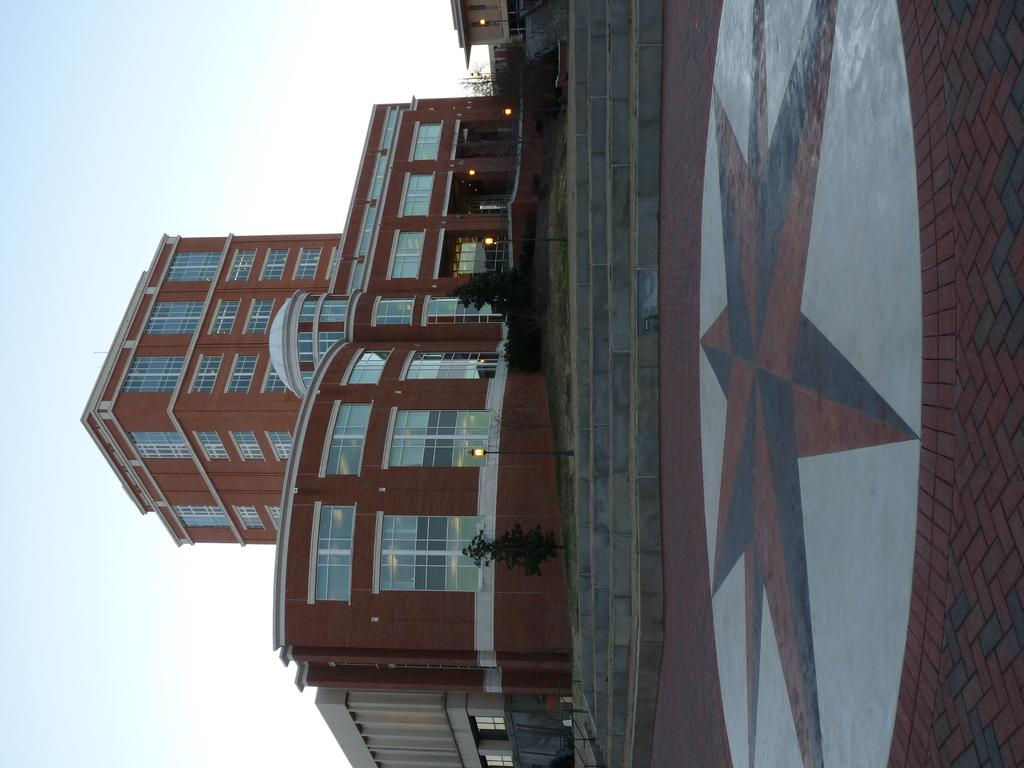What type of structure is present in the image? There is a building in the image. What can be seen in front of the building? There are plants and stairs in front of the building. Can you describe the ground in the image? The ground has a design. What is visible at the top of the image? The sky is visible at the top of the image. How many marks can be seen on the building? There are no marks visible on the building in the image. 